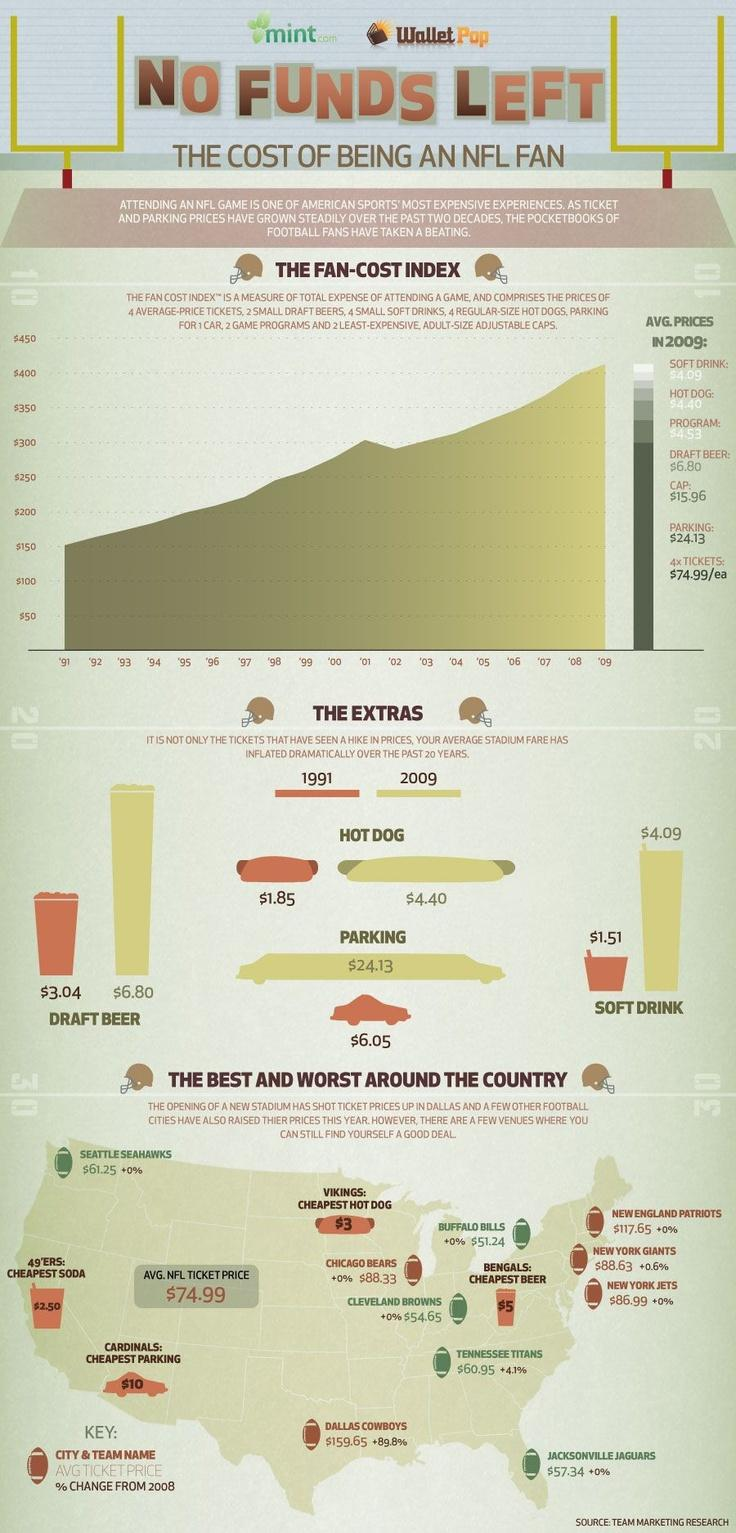Specify some key components in this picture. In 2009, the price of draft beer was $3.76, which was higher than the price of draft beer in 1991, which was $2.38. The price of parking in 2009 was $18.08 more than the price in 1991. In 2009, the price of a hot dog was $2.55, which was higher than the price in 1991, when the cost of a hot dog was $2.10. The average cost of a program and a draft beer when purchased together is $11.33. The price of a soft drink in 2009 was $2.58, which was higher than the price of a soft drink in 1991, which was $2.58. 